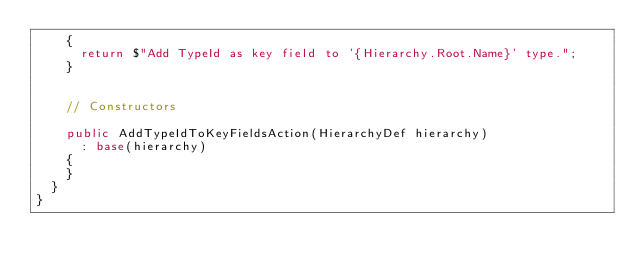Convert code to text. <code><loc_0><loc_0><loc_500><loc_500><_C#_>    {
      return $"Add TypeId as key field to '{Hierarchy.Root.Name}' type.";
    }


    // Constructors

    public AddTypeIdToKeyFieldsAction(HierarchyDef hierarchy)
      : base(hierarchy)
    {
    }
  }
}</code> 